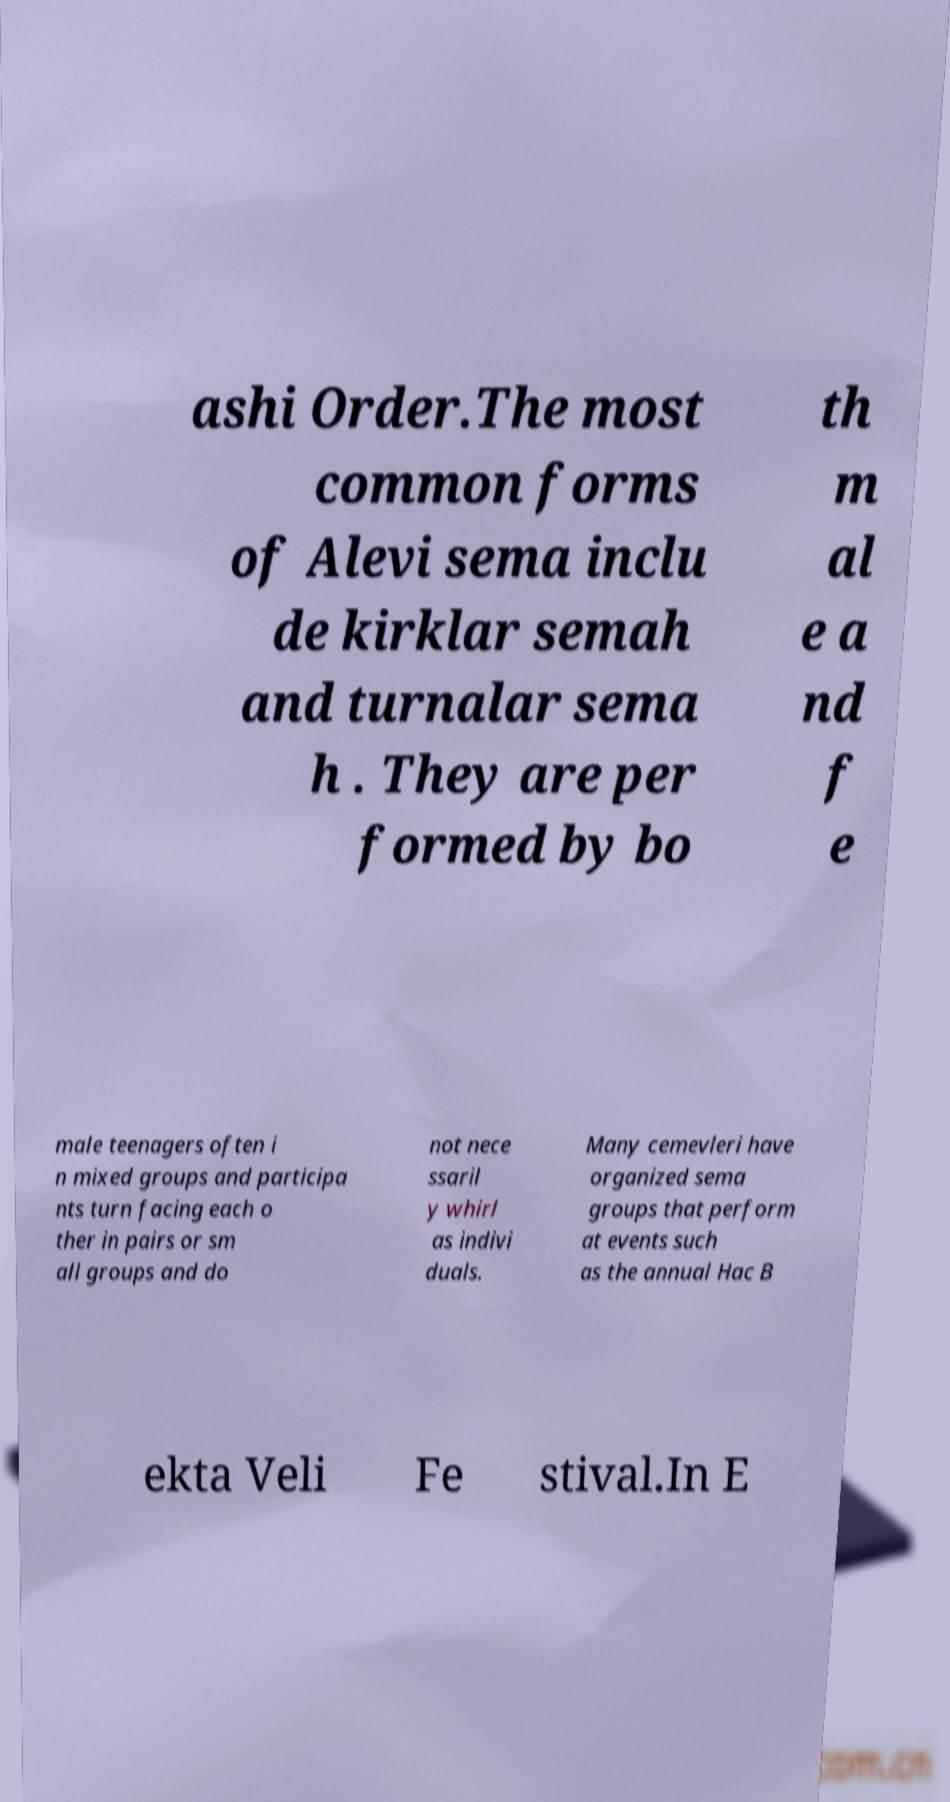I need the written content from this picture converted into text. Can you do that? ashi Order.The most common forms of Alevi sema inclu de kirklar semah and turnalar sema h . They are per formed by bo th m al e a nd f e male teenagers often i n mixed groups and participa nts turn facing each o ther in pairs or sm all groups and do not nece ssaril y whirl as indivi duals. Many cemevleri have organized sema groups that perform at events such as the annual Hac B ekta Veli Fe stival.In E 